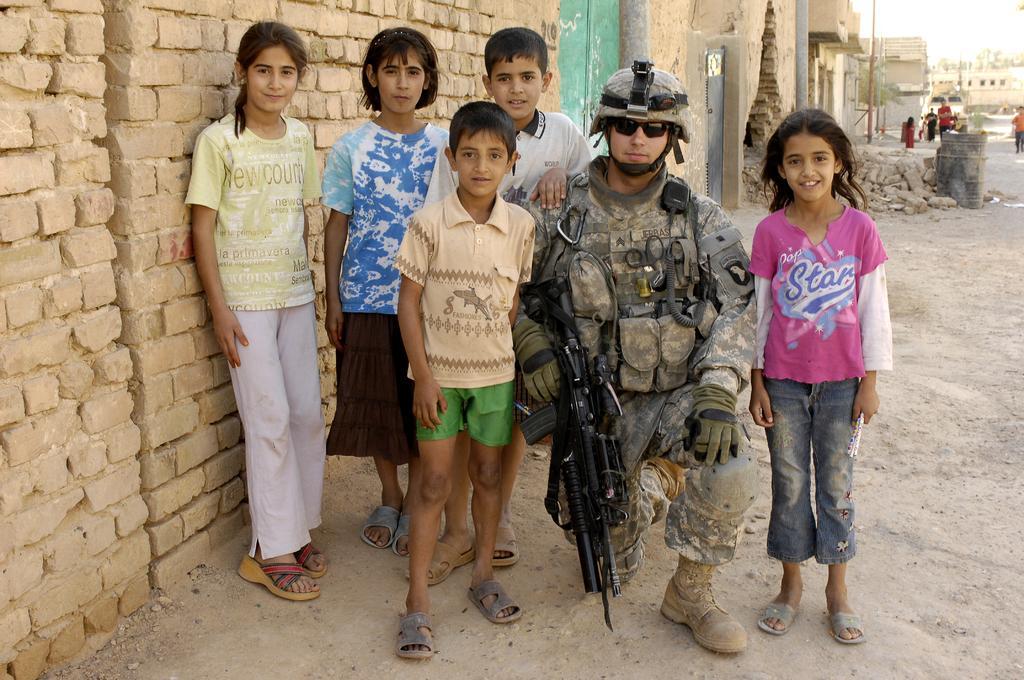Describe this image in one or two sentences. In this image we can see few people standing on the ground and a person is wearing uniform is holding a gun, there are few buildings on the left side and in the background there are few people and buildings and a pole. 